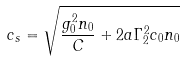<formula> <loc_0><loc_0><loc_500><loc_500>c _ { s } = \sqrt { \frac { g ^ { 2 } _ { 0 } n _ { 0 } } { C } + 2 a \Gamma _ { 2 } ^ { 2 } c _ { 0 } n _ { 0 } }</formula> 